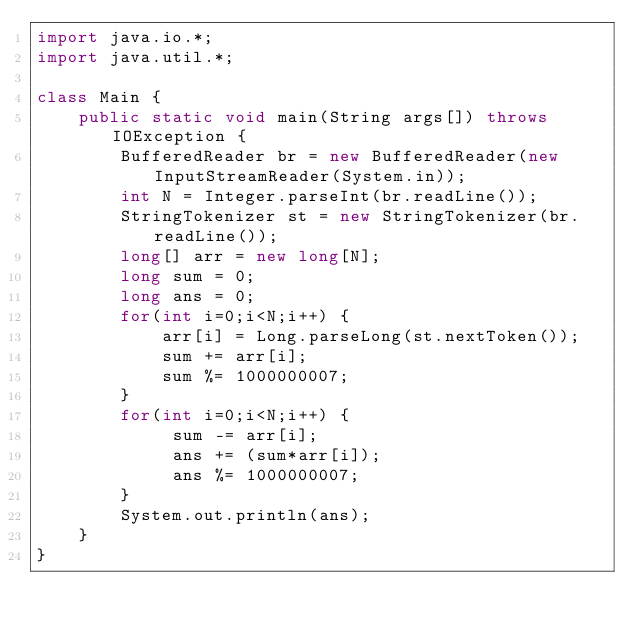<code> <loc_0><loc_0><loc_500><loc_500><_Java_>import java.io.*;
import java.util.*;

class Main {
 	public static void main(String args[]) throws IOException {
     	BufferedReader br = new BufferedReader(new InputStreamReader(System.in));
      	int N = Integer.parseInt(br.readLine());
      	StringTokenizer st = new StringTokenizer(br.readLine());
      	long[] arr = new long[N];
      	long sum = 0;
      	long ans = 0;
      	for(int i=0;i<N;i++) {
         	arr[i] = Long.parseLong(st.nextToken()); 
          	sum += arr[i];
          	sum %= 1000000007;
        }
      	for(int i=0;i<N;i++) {
          	 sum -= arr[i];
         	 ans += (sum*arr[i]);
          	 ans %= 1000000007;
        }
      	System.out.println(ans);
    }
}</code> 